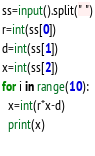Convert code to text. <code><loc_0><loc_0><loc_500><loc_500><_Python_>ss=input().split(" ")
r=int(ss[0])
d=int(ss[1])
x=int(ss[2])
for i in range(10):
  x=int(r*x-d)
  print(x)
  </code> 